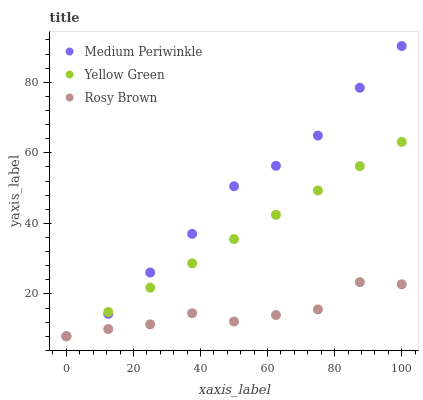Does Rosy Brown have the minimum area under the curve?
Answer yes or no. Yes. Does Medium Periwinkle have the maximum area under the curve?
Answer yes or no. Yes. Does Yellow Green have the minimum area under the curve?
Answer yes or no. No. Does Yellow Green have the maximum area under the curve?
Answer yes or no. No. Is Yellow Green the smoothest?
Answer yes or no. Yes. Is Rosy Brown the roughest?
Answer yes or no. Yes. Is Medium Periwinkle the smoothest?
Answer yes or no. No. Is Medium Periwinkle the roughest?
Answer yes or no. No. Does Rosy Brown have the lowest value?
Answer yes or no. Yes. Does Medium Periwinkle have the highest value?
Answer yes or no. Yes. Does Yellow Green have the highest value?
Answer yes or no. No. Does Medium Periwinkle intersect Yellow Green?
Answer yes or no. Yes. Is Medium Periwinkle less than Yellow Green?
Answer yes or no. No. Is Medium Periwinkle greater than Yellow Green?
Answer yes or no. No. 